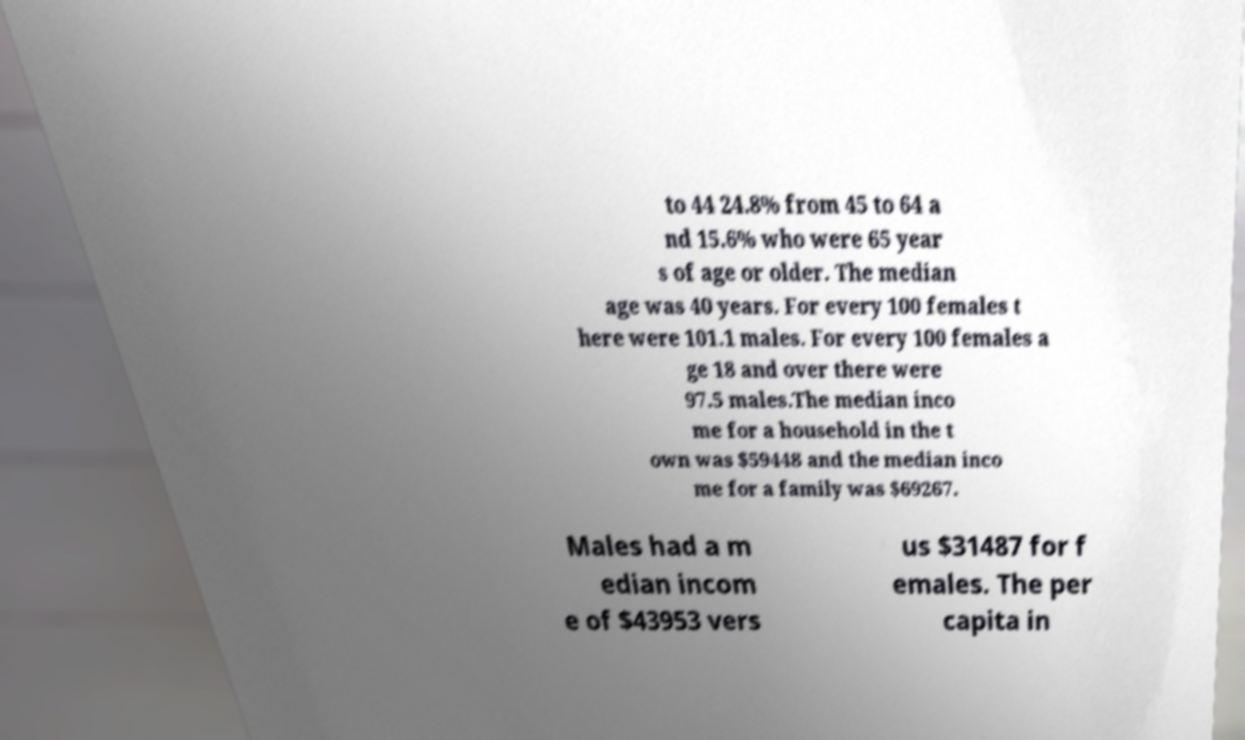What messages or text are displayed in this image? I need them in a readable, typed format. to 44 24.8% from 45 to 64 a nd 15.6% who were 65 year s of age or older. The median age was 40 years. For every 100 females t here were 101.1 males. For every 100 females a ge 18 and over there were 97.5 males.The median inco me for a household in the t own was $59448 and the median inco me for a family was $69267. Males had a m edian incom e of $43953 vers us $31487 for f emales. The per capita in 